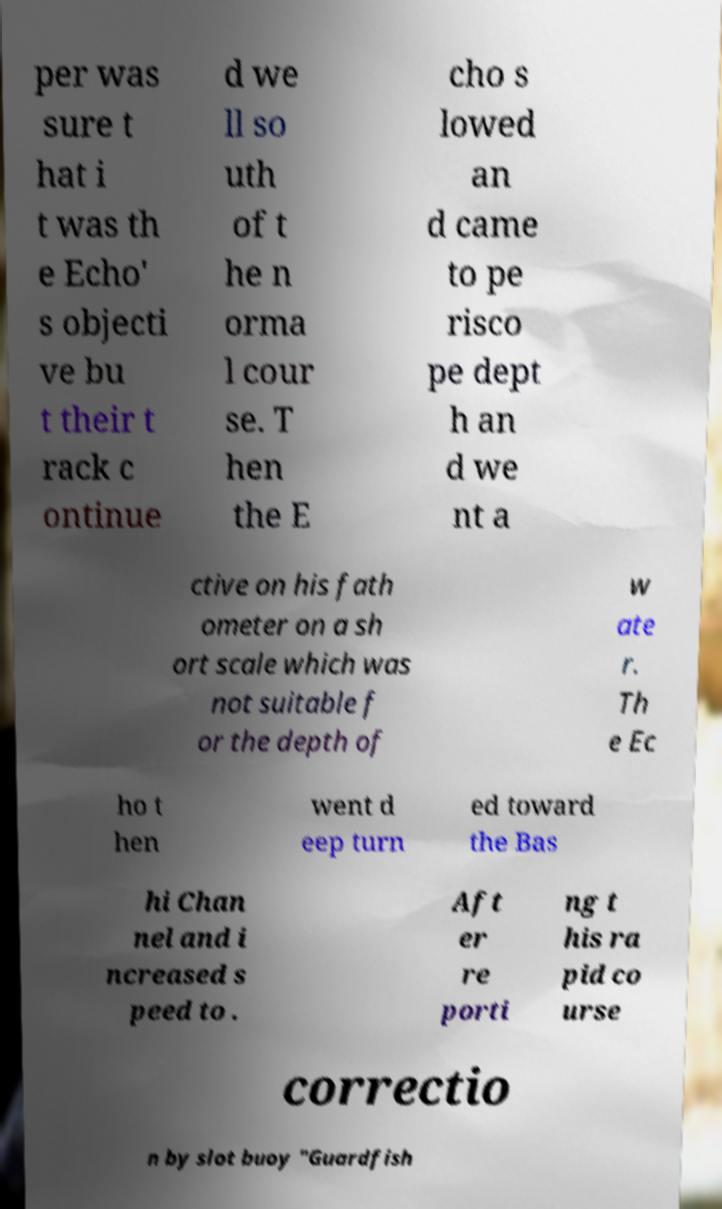What messages or text are displayed in this image? I need them in a readable, typed format. per was sure t hat i t was th e Echo' s objecti ve bu t their t rack c ontinue d we ll so uth of t he n orma l cour se. T hen the E cho s lowed an d came to pe risco pe dept h an d we nt a ctive on his fath ometer on a sh ort scale which was not suitable f or the depth of w ate r. Th e Ec ho t hen went d eep turn ed toward the Bas hi Chan nel and i ncreased s peed to . Aft er re porti ng t his ra pid co urse correctio n by slot buoy "Guardfish 